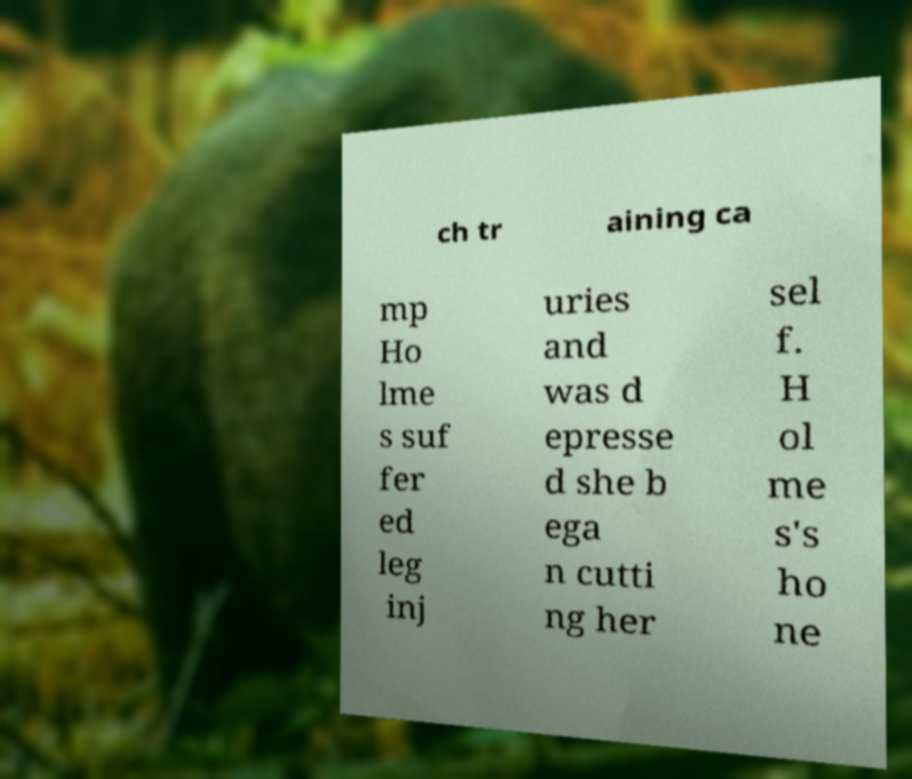I need the written content from this picture converted into text. Can you do that? ch tr aining ca mp Ho lme s suf fer ed leg inj uries and was d epresse d she b ega n cutti ng her sel f. H ol me s's ho ne 